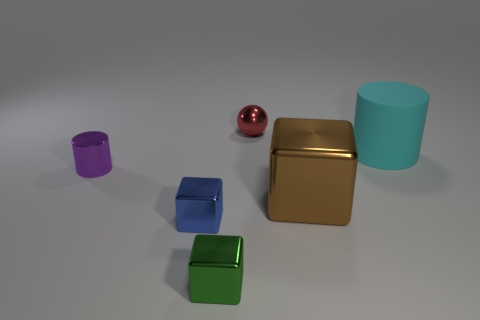In terms of size, how do the objects compare to one another? The gold and green cuboid objects are the largest, followed by the turquoise cylinder. The purple cylinder is smaller than the turquoise one, and the smallest object is the red sphere. 